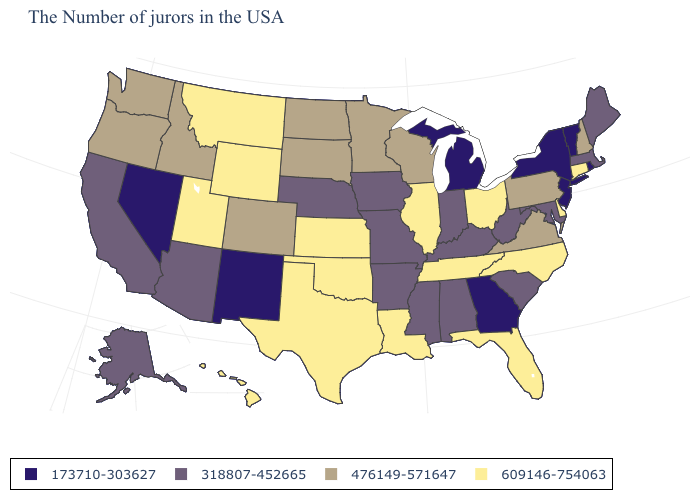Among the states that border Kentucky , does Illinois have the highest value?
Answer briefly. Yes. What is the value of New York?
Write a very short answer. 173710-303627. What is the highest value in the West ?
Quick response, please. 609146-754063. What is the value of Virginia?
Quick response, please. 476149-571647. What is the lowest value in the West?
Quick response, please. 173710-303627. What is the lowest value in the USA?
Quick response, please. 173710-303627. What is the value of Kentucky?
Be succinct. 318807-452665. What is the lowest value in states that border Washington?
Write a very short answer. 476149-571647. Does New York have the same value as Kentucky?
Concise answer only. No. What is the value of Rhode Island?
Be succinct. 173710-303627. What is the highest value in the USA?
Keep it brief. 609146-754063. Among the states that border Missouri , which have the lowest value?
Quick response, please. Kentucky, Arkansas, Iowa, Nebraska. Name the states that have a value in the range 609146-754063?
Keep it brief. Connecticut, Delaware, North Carolina, Ohio, Florida, Tennessee, Illinois, Louisiana, Kansas, Oklahoma, Texas, Wyoming, Utah, Montana, Hawaii. Does Maryland have the highest value in the USA?
Keep it brief. No. What is the value of Michigan?
Write a very short answer. 173710-303627. 